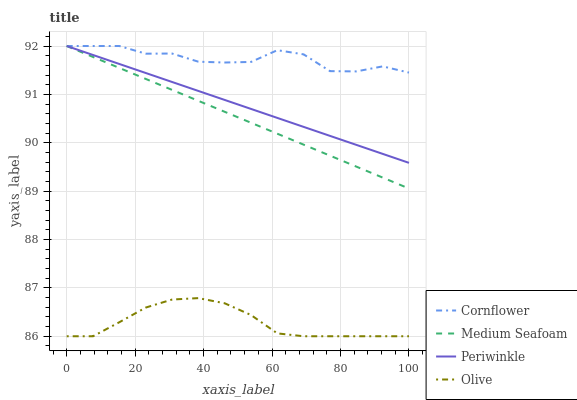Does Periwinkle have the minimum area under the curve?
Answer yes or no. No. Does Periwinkle have the maximum area under the curve?
Answer yes or no. No. Is Periwinkle the smoothest?
Answer yes or no. No. Is Periwinkle the roughest?
Answer yes or no. No. Does Periwinkle have the lowest value?
Answer yes or no. No. Is Olive less than Medium Seafoam?
Answer yes or no. Yes. Is Medium Seafoam greater than Olive?
Answer yes or no. Yes. Does Olive intersect Medium Seafoam?
Answer yes or no. No. 